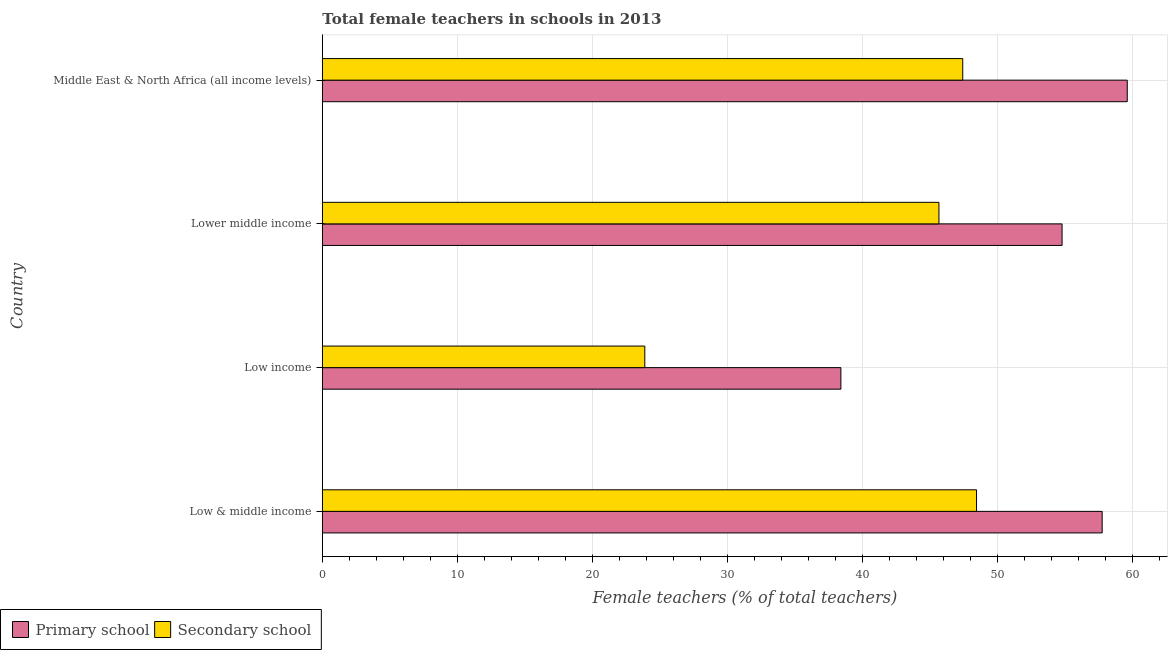How many groups of bars are there?
Your answer should be very brief. 4. Are the number of bars per tick equal to the number of legend labels?
Provide a short and direct response. Yes. How many bars are there on the 4th tick from the top?
Give a very brief answer. 2. How many bars are there on the 3rd tick from the bottom?
Your answer should be compact. 2. What is the label of the 1st group of bars from the top?
Offer a very short reply. Middle East & North Africa (all income levels). In how many cases, is the number of bars for a given country not equal to the number of legend labels?
Ensure brevity in your answer.  0. What is the percentage of female teachers in secondary schools in Low income?
Provide a succinct answer. 23.89. Across all countries, what is the maximum percentage of female teachers in primary schools?
Provide a succinct answer. 59.62. Across all countries, what is the minimum percentage of female teachers in primary schools?
Offer a terse response. 38.41. In which country was the percentage of female teachers in primary schools maximum?
Offer a terse response. Middle East & North Africa (all income levels). What is the total percentage of female teachers in secondary schools in the graph?
Make the answer very short. 165.46. What is the difference between the percentage of female teachers in secondary schools in Low & middle income and that in Lower middle income?
Your answer should be compact. 2.78. What is the difference between the percentage of female teachers in primary schools in Middle East & North Africa (all income levels) and the percentage of female teachers in secondary schools in Lower middle income?
Offer a terse response. 13.95. What is the average percentage of female teachers in secondary schools per country?
Your answer should be compact. 41.37. What is the difference between the percentage of female teachers in secondary schools and percentage of female teachers in primary schools in Low & middle income?
Provide a succinct answer. -9.31. What is the ratio of the percentage of female teachers in primary schools in Low income to that in Middle East & North Africa (all income levels)?
Keep it short and to the point. 0.64. What is the difference between the highest and the second highest percentage of female teachers in secondary schools?
Give a very brief answer. 1.02. What is the difference between the highest and the lowest percentage of female teachers in secondary schools?
Ensure brevity in your answer.  24.57. What does the 1st bar from the top in Middle East & North Africa (all income levels) represents?
Give a very brief answer. Secondary school. What does the 1st bar from the bottom in Middle East & North Africa (all income levels) represents?
Make the answer very short. Primary school. What is the difference between two consecutive major ticks on the X-axis?
Offer a terse response. 10. Does the graph contain any zero values?
Your answer should be very brief. No. Does the graph contain grids?
Your response must be concise. Yes. Where does the legend appear in the graph?
Your answer should be very brief. Bottom left. What is the title of the graph?
Your answer should be compact. Total female teachers in schools in 2013. What is the label or title of the X-axis?
Give a very brief answer. Female teachers (% of total teachers). What is the Female teachers (% of total teachers) of Primary school in Low & middle income?
Your answer should be compact. 57.77. What is the Female teachers (% of total teachers) in Secondary school in Low & middle income?
Offer a very short reply. 48.46. What is the Female teachers (% of total teachers) in Primary school in Low income?
Ensure brevity in your answer.  38.41. What is the Female teachers (% of total teachers) of Secondary school in Low income?
Provide a succinct answer. 23.89. What is the Female teachers (% of total teachers) of Primary school in Lower middle income?
Your answer should be very brief. 54.8. What is the Female teachers (% of total teachers) in Secondary school in Lower middle income?
Your answer should be compact. 45.68. What is the Female teachers (% of total teachers) in Primary school in Middle East & North Africa (all income levels)?
Your answer should be very brief. 59.62. What is the Female teachers (% of total teachers) in Secondary school in Middle East & North Africa (all income levels)?
Provide a short and direct response. 47.44. Across all countries, what is the maximum Female teachers (% of total teachers) in Primary school?
Your answer should be very brief. 59.62. Across all countries, what is the maximum Female teachers (% of total teachers) in Secondary school?
Give a very brief answer. 48.46. Across all countries, what is the minimum Female teachers (% of total teachers) of Primary school?
Provide a short and direct response. 38.41. Across all countries, what is the minimum Female teachers (% of total teachers) of Secondary school?
Your answer should be very brief. 23.89. What is the total Female teachers (% of total teachers) of Primary school in the graph?
Offer a very short reply. 210.6. What is the total Female teachers (% of total teachers) in Secondary school in the graph?
Provide a short and direct response. 165.46. What is the difference between the Female teachers (% of total teachers) in Primary school in Low & middle income and that in Low income?
Offer a terse response. 19.35. What is the difference between the Female teachers (% of total teachers) of Secondary school in Low & middle income and that in Low income?
Keep it short and to the point. 24.57. What is the difference between the Female teachers (% of total teachers) of Primary school in Low & middle income and that in Lower middle income?
Keep it short and to the point. 2.97. What is the difference between the Female teachers (% of total teachers) in Secondary school in Low & middle income and that in Lower middle income?
Your answer should be very brief. 2.78. What is the difference between the Female teachers (% of total teachers) of Primary school in Low & middle income and that in Middle East & North Africa (all income levels)?
Your answer should be very brief. -1.86. What is the difference between the Female teachers (% of total teachers) in Secondary school in Low & middle income and that in Middle East & North Africa (all income levels)?
Your answer should be compact. 1.02. What is the difference between the Female teachers (% of total teachers) in Primary school in Low income and that in Lower middle income?
Your response must be concise. -16.38. What is the difference between the Female teachers (% of total teachers) of Secondary school in Low income and that in Lower middle income?
Your response must be concise. -21.79. What is the difference between the Female teachers (% of total teachers) of Primary school in Low income and that in Middle East & North Africa (all income levels)?
Give a very brief answer. -21.21. What is the difference between the Female teachers (% of total teachers) of Secondary school in Low income and that in Middle East & North Africa (all income levels)?
Offer a very short reply. -23.55. What is the difference between the Female teachers (% of total teachers) of Primary school in Lower middle income and that in Middle East & North Africa (all income levels)?
Ensure brevity in your answer.  -4.83. What is the difference between the Female teachers (% of total teachers) of Secondary school in Lower middle income and that in Middle East & North Africa (all income levels)?
Your answer should be very brief. -1.76. What is the difference between the Female teachers (% of total teachers) in Primary school in Low & middle income and the Female teachers (% of total teachers) in Secondary school in Low income?
Give a very brief answer. 33.88. What is the difference between the Female teachers (% of total teachers) of Primary school in Low & middle income and the Female teachers (% of total teachers) of Secondary school in Lower middle income?
Provide a succinct answer. 12.09. What is the difference between the Female teachers (% of total teachers) of Primary school in Low & middle income and the Female teachers (% of total teachers) of Secondary school in Middle East & North Africa (all income levels)?
Provide a succinct answer. 10.33. What is the difference between the Female teachers (% of total teachers) in Primary school in Low income and the Female teachers (% of total teachers) in Secondary school in Lower middle income?
Provide a succinct answer. -7.26. What is the difference between the Female teachers (% of total teachers) of Primary school in Low income and the Female teachers (% of total teachers) of Secondary school in Middle East & North Africa (all income levels)?
Provide a succinct answer. -9.03. What is the difference between the Female teachers (% of total teachers) of Primary school in Lower middle income and the Female teachers (% of total teachers) of Secondary school in Middle East & North Africa (all income levels)?
Your answer should be compact. 7.36. What is the average Female teachers (% of total teachers) of Primary school per country?
Keep it short and to the point. 52.65. What is the average Female teachers (% of total teachers) in Secondary school per country?
Make the answer very short. 41.37. What is the difference between the Female teachers (% of total teachers) in Primary school and Female teachers (% of total teachers) in Secondary school in Low & middle income?
Make the answer very short. 9.31. What is the difference between the Female teachers (% of total teachers) of Primary school and Female teachers (% of total teachers) of Secondary school in Low income?
Offer a very short reply. 14.53. What is the difference between the Female teachers (% of total teachers) of Primary school and Female teachers (% of total teachers) of Secondary school in Lower middle income?
Offer a terse response. 9.12. What is the difference between the Female teachers (% of total teachers) in Primary school and Female teachers (% of total teachers) in Secondary school in Middle East & North Africa (all income levels)?
Offer a very short reply. 12.19. What is the ratio of the Female teachers (% of total teachers) of Primary school in Low & middle income to that in Low income?
Your answer should be very brief. 1.5. What is the ratio of the Female teachers (% of total teachers) in Secondary school in Low & middle income to that in Low income?
Offer a very short reply. 2.03. What is the ratio of the Female teachers (% of total teachers) in Primary school in Low & middle income to that in Lower middle income?
Offer a very short reply. 1.05. What is the ratio of the Female teachers (% of total teachers) of Secondary school in Low & middle income to that in Lower middle income?
Make the answer very short. 1.06. What is the ratio of the Female teachers (% of total teachers) in Primary school in Low & middle income to that in Middle East & North Africa (all income levels)?
Ensure brevity in your answer.  0.97. What is the ratio of the Female teachers (% of total teachers) of Secondary school in Low & middle income to that in Middle East & North Africa (all income levels)?
Provide a succinct answer. 1.02. What is the ratio of the Female teachers (% of total teachers) in Primary school in Low income to that in Lower middle income?
Provide a short and direct response. 0.7. What is the ratio of the Female teachers (% of total teachers) in Secondary school in Low income to that in Lower middle income?
Your response must be concise. 0.52. What is the ratio of the Female teachers (% of total teachers) of Primary school in Low income to that in Middle East & North Africa (all income levels)?
Provide a short and direct response. 0.64. What is the ratio of the Female teachers (% of total teachers) of Secondary school in Low income to that in Middle East & North Africa (all income levels)?
Your answer should be compact. 0.5. What is the ratio of the Female teachers (% of total teachers) in Primary school in Lower middle income to that in Middle East & North Africa (all income levels)?
Give a very brief answer. 0.92. What is the ratio of the Female teachers (% of total teachers) of Secondary school in Lower middle income to that in Middle East & North Africa (all income levels)?
Ensure brevity in your answer.  0.96. What is the difference between the highest and the second highest Female teachers (% of total teachers) in Primary school?
Provide a succinct answer. 1.86. What is the difference between the highest and the second highest Female teachers (% of total teachers) in Secondary school?
Offer a terse response. 1.02. What is the difference between the highest and the lowest Female teachers (% of total teachers) of Primary school?
Offer a terse response. 21.21. What is the difference between the highest and the lowest Female teachers (% of total teachers) in Secondary school?
Provide a succinct answer. 24.57. 